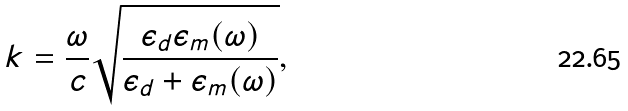Convert formula to latex. <formula><loc_0><loc_0><loc_500><loc_500>k = \frac { \omega } { c } \sqrt { \frac { \epsilon _ { d } \epsilon _ { m } ( \omega ) } { \epsilon _ { d } + \epsilon _ { m } ( \omega ) } } ,</formula> 